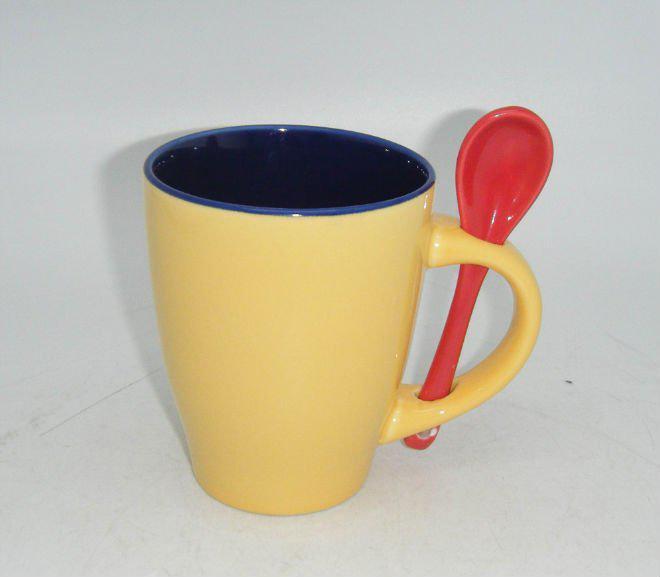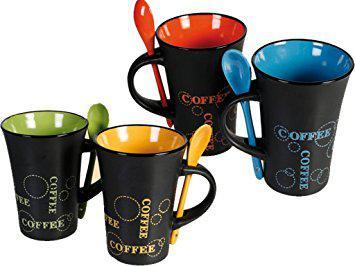The first image is the image on the left, the second image is the image on the right. Analyze the images presented: Is the assertion "One image shows a single blue-lined white cup with a blue spoon." valid? Answer yes or no. No. 